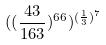<formula> <loc_0><loc_0><loc_500><loc_500>( ( \frac { 4 3 } { 1 6 3 } ) ^ { 6 6 } ) ^ { ( \frac { 1 } { 3 } ) ^ { 7 } }</formula> 